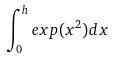Convert formula to latex. <formula><loc_0><loc_0><loc_500><loc_500>\int _ { 0 } ^ { h } e x p ( x ^ { 2 } ) d x</formula> 